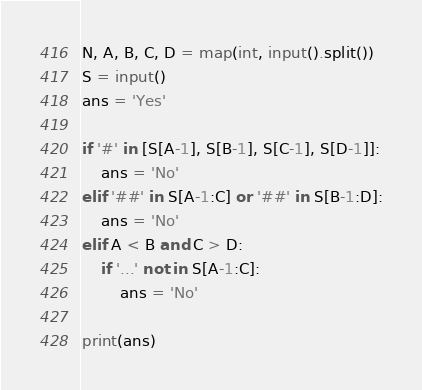Convert code to text. <code><loc_0><loc_0><loc_500><loc_500><_Python_>N, A, B, C, D = map(int, input().split())
S = input()
ans = 'Yes'

if '#' in [S[A-1], S[B-1], S[C-1], S[D-1]]:
    ans = 'No'
elif '##' in S[A-1:C] or '##' in S[B-1:D]:
    ans = 'No'
elif A < B and C > D:
    if '...' not in S[A-1:C]:
        ans = 'No'

print(ans)</code> 